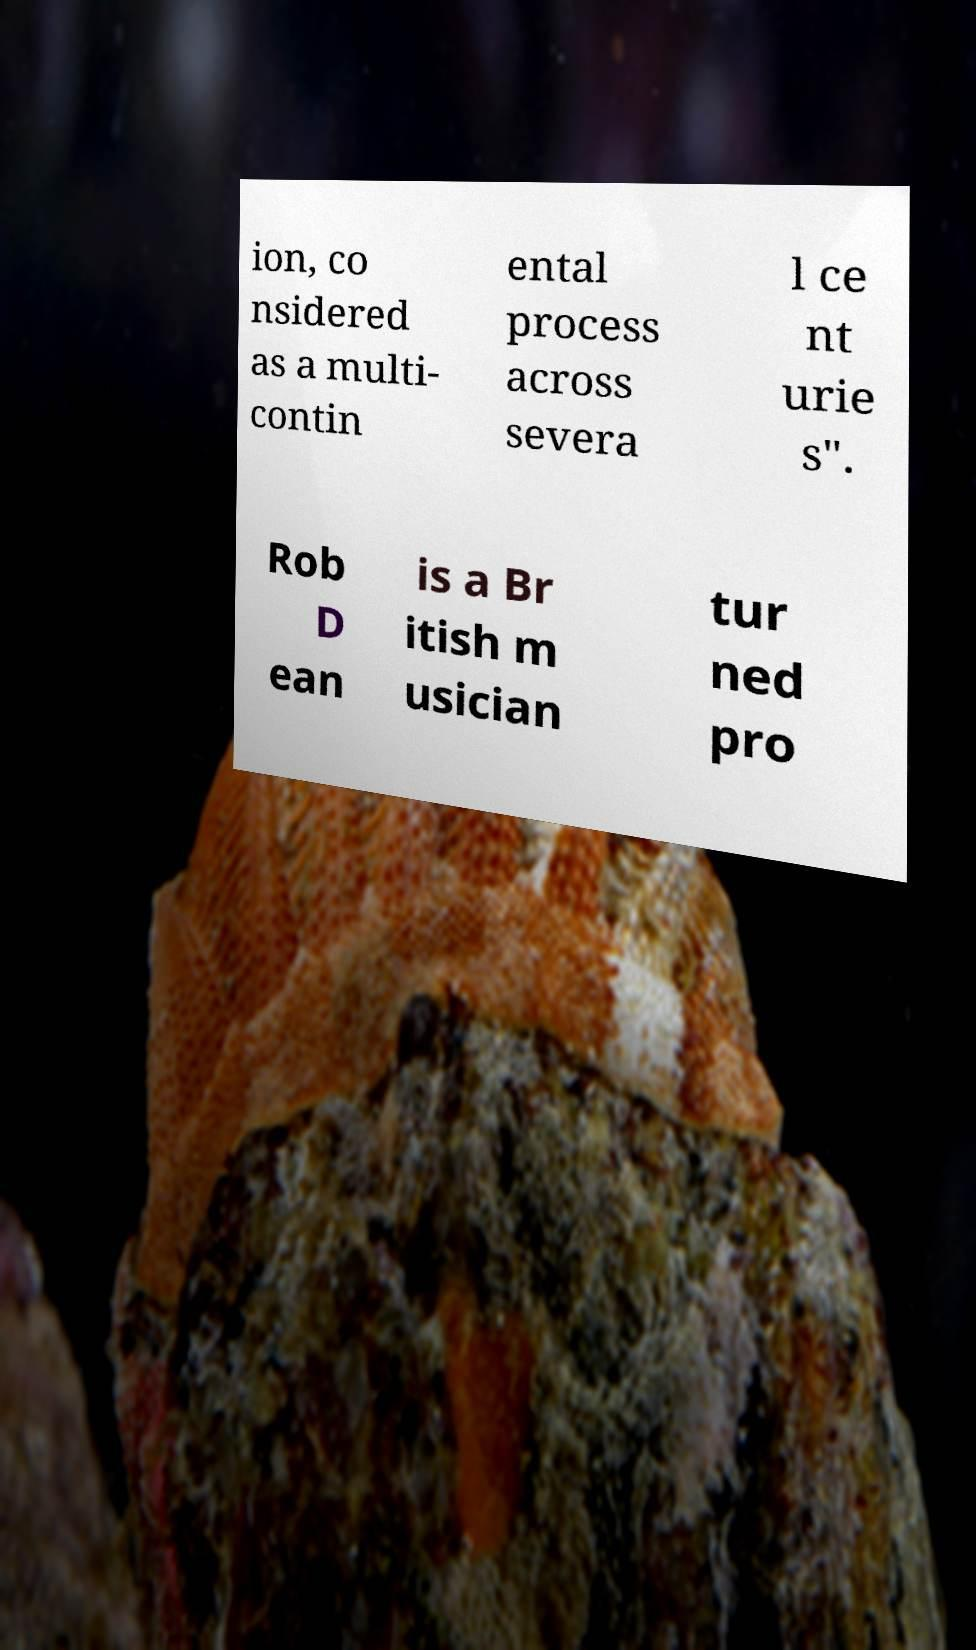Please read and relay the text visible in this image. What does it say? ion, co nsidered as a multi- contin ental process across severa l ce nt urie s". Rob D ean is a Br itish m usician tur ned pro 